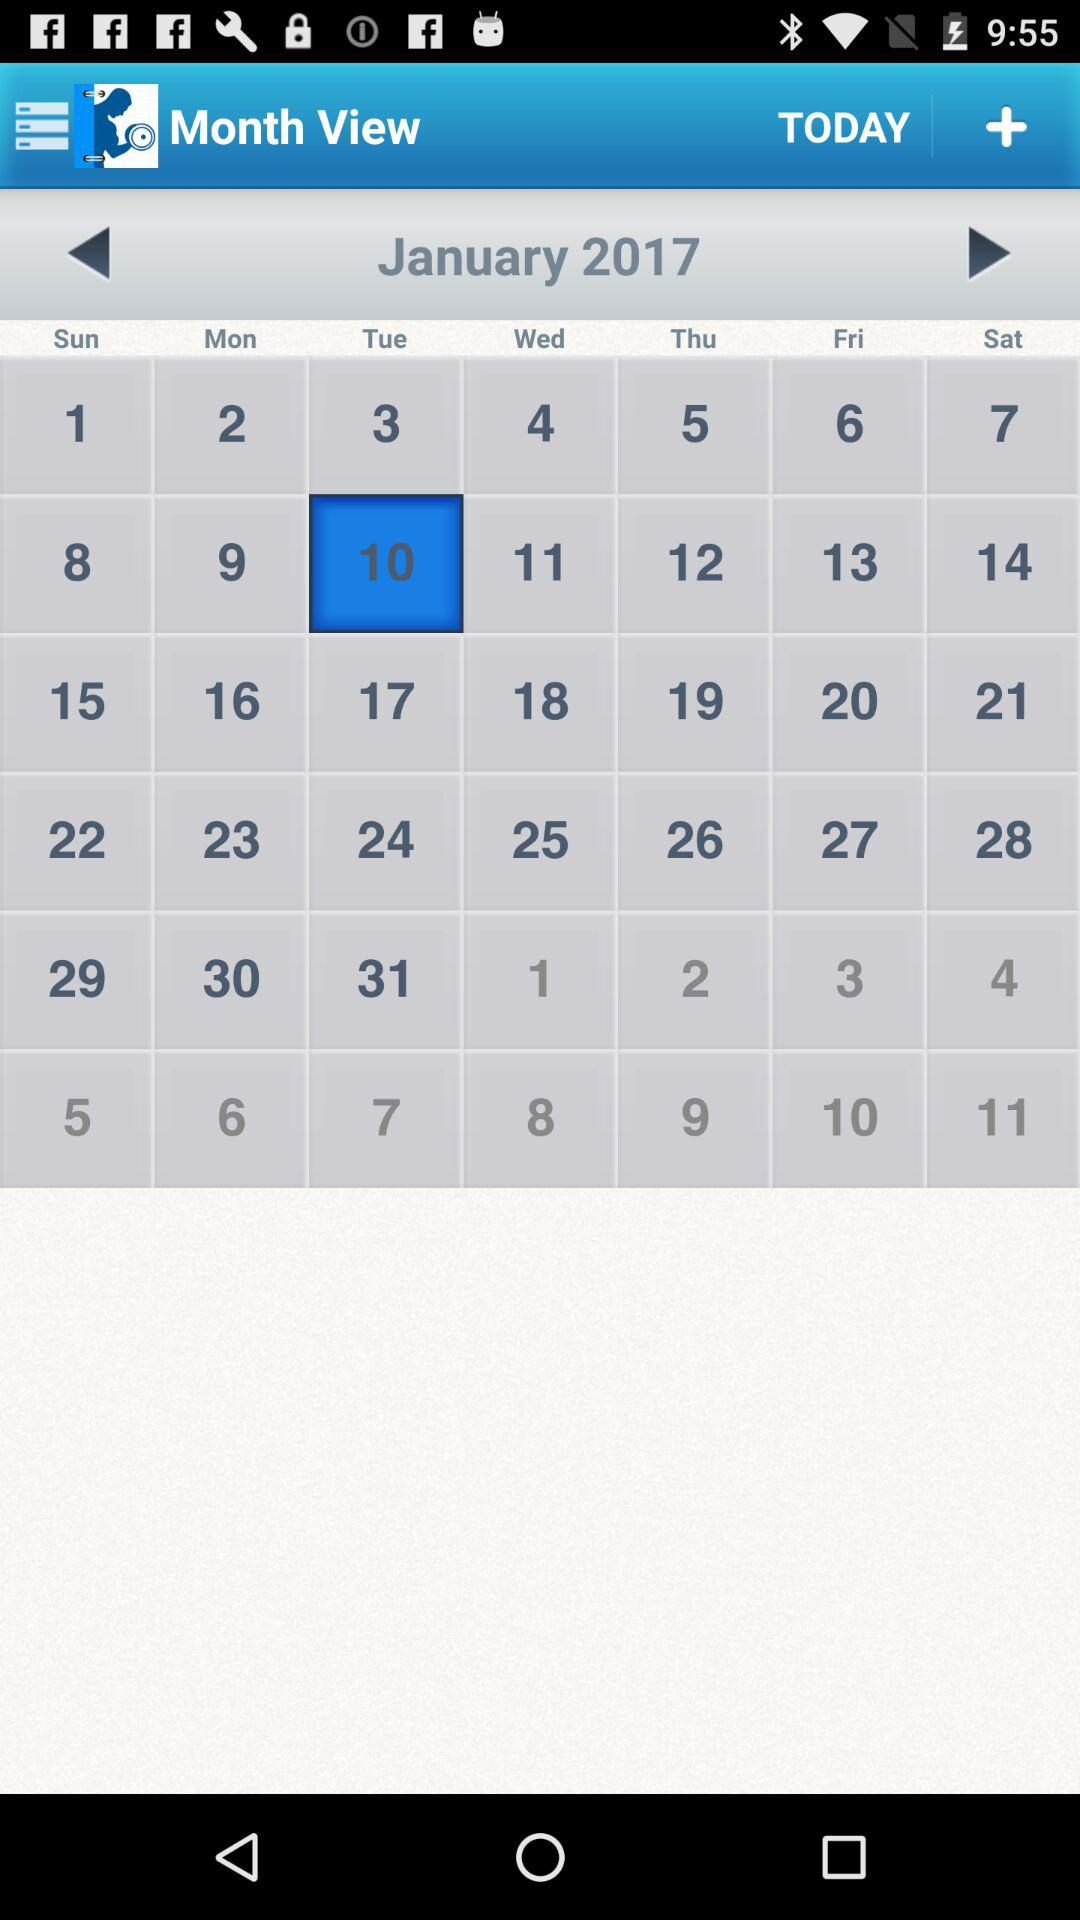What is the selected month? The selected month is January. 